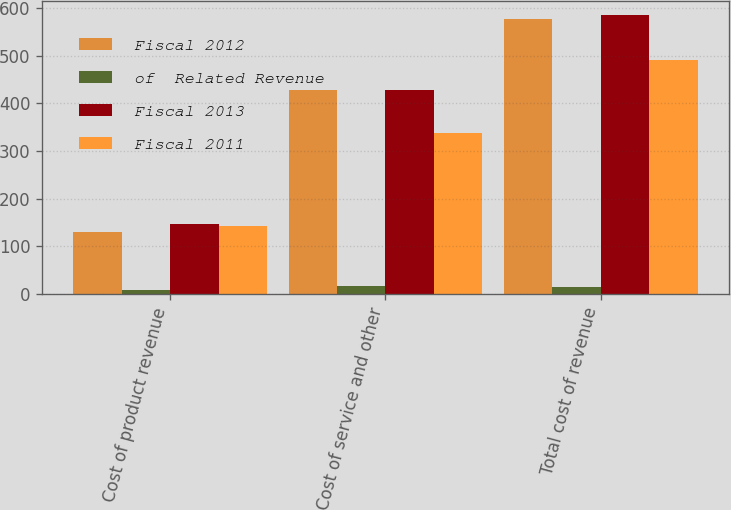Convert chart. <chart><loc_0><loc_0><loc_500><loc_500><stacked_bar_chart><ecel><fcel>Cost of product revenue<fcel>Cost of service and other<fcel>Total cost of revenue<nl><fcel>Fiscal 2012<fcel>130<fcel>429<fcel>577<nl><fcel>of  Related Revenue<fcel>9<fcel>16<fcel>14<nl><fcel>Fiscal 2013<fcel>146<fcel>429<fcel>585<nl><fcel>Fiscal 2011<fcel>143<fcel>338<fcel>490<nl></chart> 